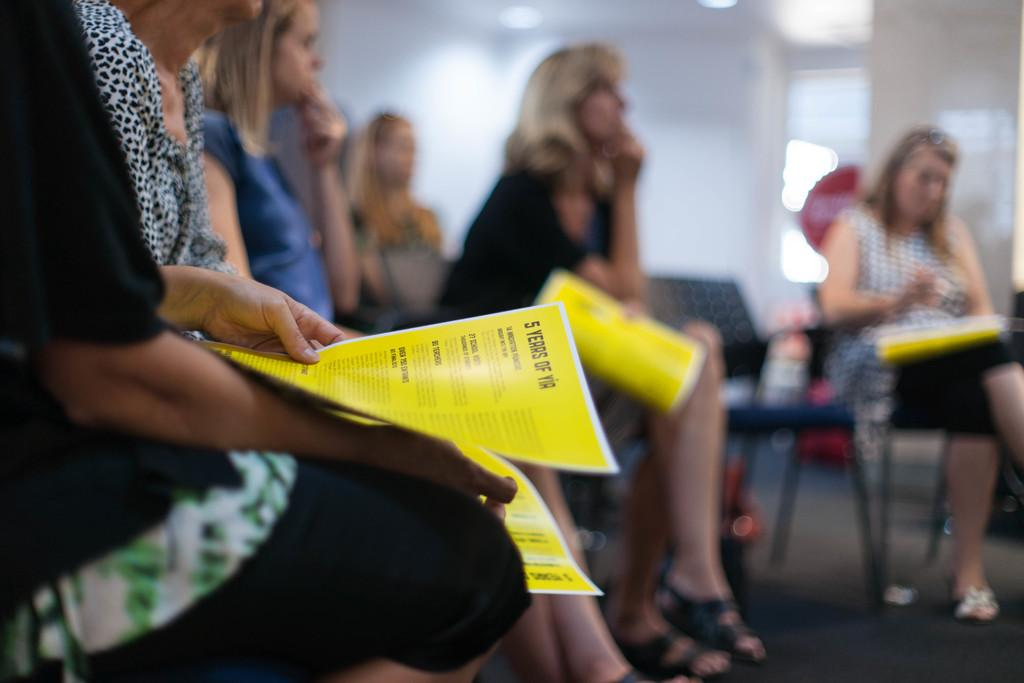What are the women in the image doing? The women are sitting in the chairs. How many chairs are visible in the image? There are empty chairs in the image in addition to the chairs with women sitting in them. What can be seen in the background of the image? There is a wall in the background of the image. What type of sack is being used for punishment in the image? There is no sack or punishment present in the image; it only shows women sitting in chairs with a wall in the background. 